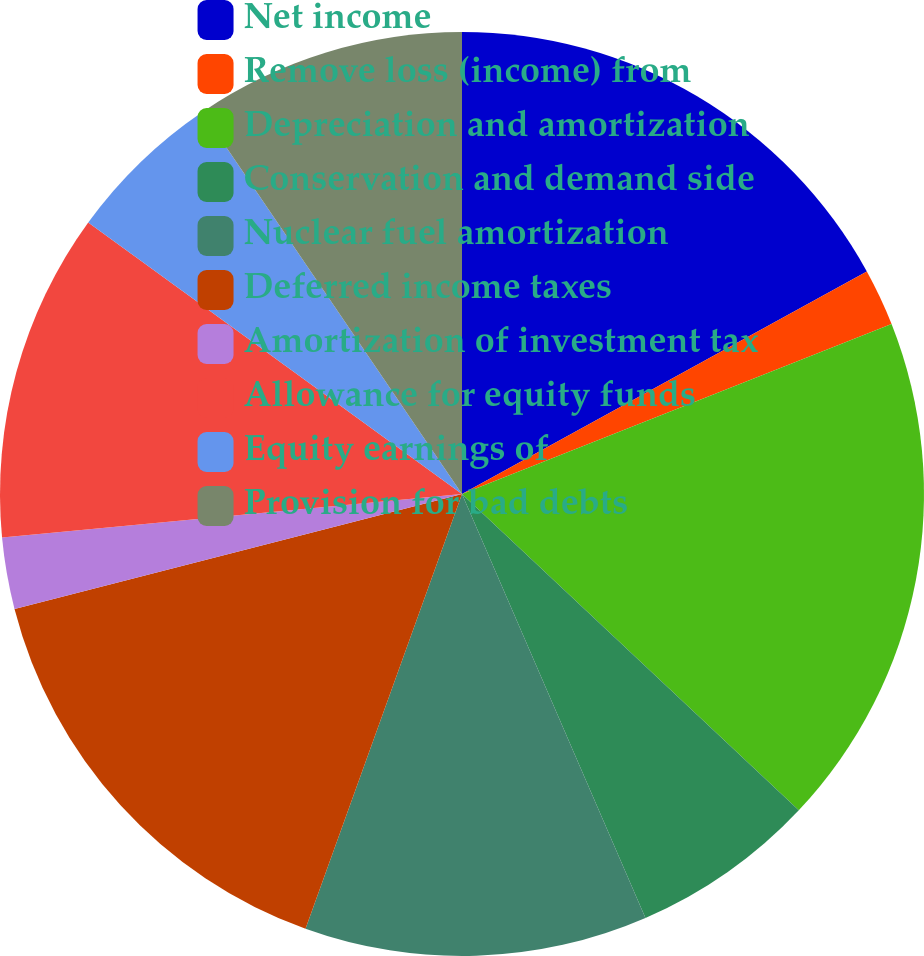<chart> <loc_0><loc_0><loc_500><loc_500><pie_chart><fcel>Net income<fcel>Remove loss (income) from<fcel>Depreciation and amortization<fcel>Conservation and demand side<fcel>Nuclear fuel amortization<fcel>Deferred income taxes<fcel>Amortization of investment tax<fcel>Allowance for equity funds<fcel>Equity earnings of<fcel>Provision for bad debts<nl><fcel>17.0%<fcel>2.0%<fcel>18.0%<fcel>6.5%<fcel>12.0%<fcel>15.5%<fcel>2.5%<fcel>11.5%<fcel>5.5%<fcel>9.5%<nl></chart> 